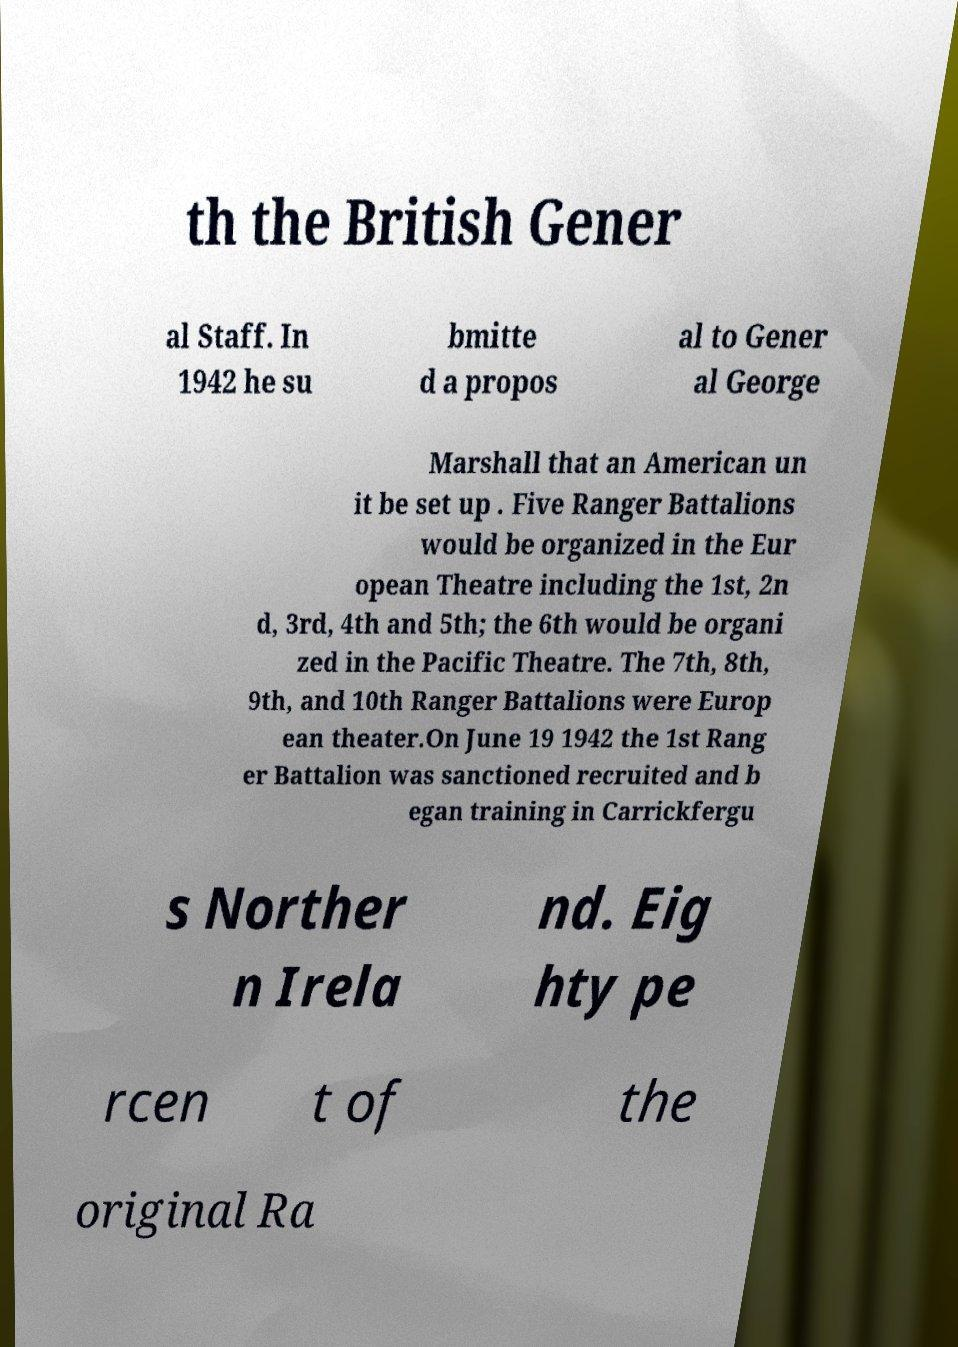Please read and relay the text visible in this image. What does it say? th the British Gener al Staff. In 1942 he su bmitte d a propos al to Gener al George Marshall that an American un it be set up . Five Ranger Battalions would be organized in the Eur opean Theatre including the 1st, 2n d, 3rd, 4th and 5th; the 6th would be organi zed in the Pacific Theatre. The 7th, 8th, 9th, and 10th Ranger Battalions were Europ ean theater.On June 19 1942 the 1st Rang er Battalion was sanctioned recruited and b egan training in Carrickfergu s Norther n Irela nd. Eig hty pe rcen t of the original Ra 